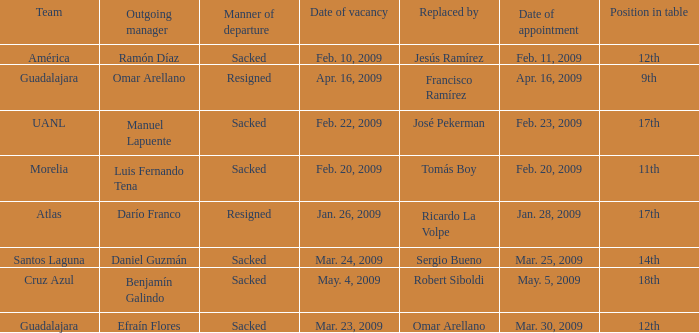What is Team, when Replaced By is "Jesús Ramírez"? América. 